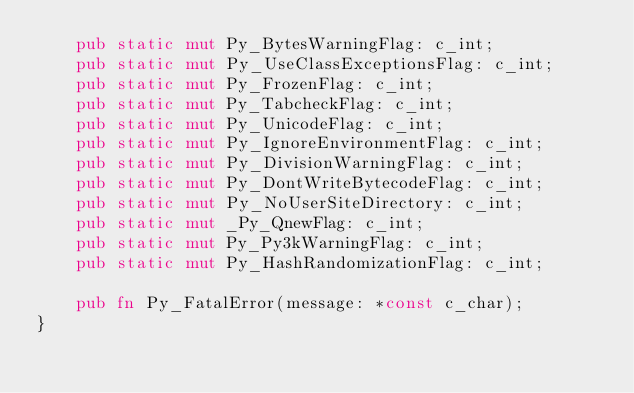Convert code to text. <code><loc_0><loc_0><loc_500><loc_500><_Rust_>    pub static mut Py_BytesWarningFlag: c_int;
    pub static mut Py_UseClassExceptionsFlag: c_int;
    pub static mut Py_FrozenFlag: c_int;
    pub static mut Py_TabcheckFlag: c_int;
    pub static mut Py_UnicodeFlag: c_int;
    pub static mut Py_IgnoreEnvironmentFlag: c_int;
    pub static mut Py_DivisionWarningFlag: c_int;
    pub static mut Py_DontWriteBytecodeFlag: c_int;
    pub static mut Py_NoUserSiteDirectory: c_int;
    pub static mut _Py_QnewFlag: c_int;
    pub static mut Py_Py3kWarningFlag: c_int;
    pub static mut Py_HashRandomizationFlag: c_int;

    pub fn Py_FatalError(message: *const c_char);
}
</code> 